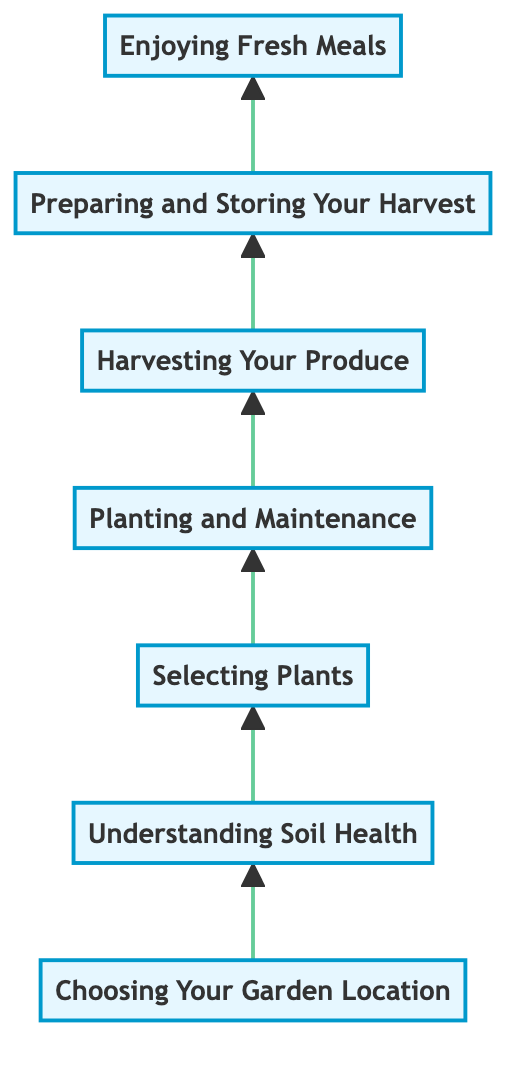What is the first step in the gardening process? The first node at the bottom of the flow chart is "Choosing Your Garden Location," indicating this is the initial step.
Answer: Choosing Your Garden Location How many steps are there in total from garden to table? By counting the nodes from "Choosing Your Garden Location" to "Enjoying Fresh Meals," there are a total of 7 steps.
Answer: 7 What is the last step in the process? The final node at the top of the flow chart is "Enjoying Fresh Meals," which represents the last action in the process.
Answer: Enjoying Fresh Meals Which step involves assessing the condition of the soil? The node "Understanding Soil Health" provides information about testing soil for pH and nutrients, indicating that this step involves soil assessment.
Answer: Understanding Soil Health What does the process flow indicate about the importance of planting and maintenance? The flow from "Selecting Plants" to "Planting and Maintenance" implies that after choosing plants, maintaining them is crucial to ensure healthy growth.
Answer: Crucial What is required before you can plant your seeds or seedlings? The chart indicates that you must first "Select Plants," as it is necessary to determine which plants to grow before planting them.
Answer: Select Plants What happens after harvesting your produce? Following "Harvesting Your Produce," the next step in the flow is "Preparing and Storing Your Harvest," indicating preparation occurs after harvesting.
Answer: Preparing and Storing Your Harvest What is the primary focus of the second step? The second step, "Understanding Soil Health," is focused on assessing soil quality and enriching it, highlighting the critical nature of soil health in gardening.
Answer: Assessing soil quality 